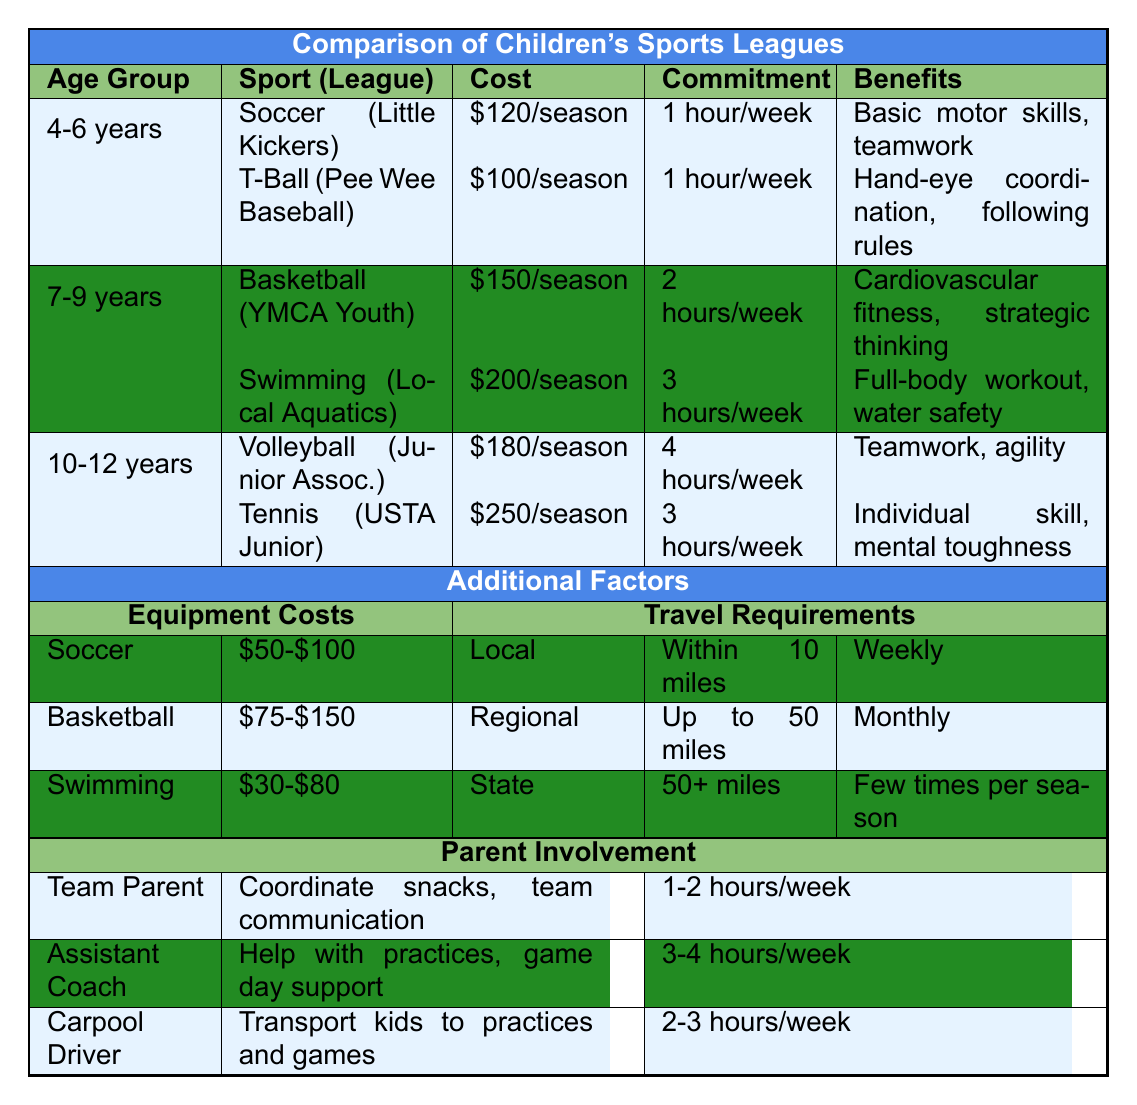What is the cost of playing soccer in the 4-6 years age group? The table shows that the cost of playing soccer (Little Kickers) in the 4-6 years age group is $120 per season.
Answer: $120/season How many hours per week do kids in the 10-12 years age group commit to volleyball? According to the table, kids in the 10-12 years age group commit to 4 hours per week for volleyball.
Answer: 4 hours/week Which sport in the 7-9 years age group has the highest cost? The table lists swimming with a cost of $200/season, which is higher than basketball's $150/season in the 7-9 years age group.
Answer: Swimming What are the total hours per week committed to sports for the 10-12 years age group? Volleyball requires 4 hours/week and tennis requires 3 hours/week. The total commitment is 4 + 3 = 7 hours/week.
Answer: 7 hours/week Is there a sport in the 4-6 years age group that has a commitment level higher than 1 hour per week? The table indicates that both soccer and T-Ball in this age group have a commitment of 1 hour/week, so there is no sport with a commitment level higher than that.
Answer: No Which sport requires the least amount of equipment cost in the 7-9 years age group? The equipment cost for basketball ranges from $75-$150 and for swimming, it ranges from $30-$80. Swimming has the least equipment cost.
Answer: Swimming If a parent wants to be a team parent for basketball in the 7-9 years group, what is their weekly time commitment? The table states that a team parent has a time commitment of 1-2 hours/week, which applies to the basketball in the 7-9 years group as well.
Answer: 1-2 hours/week What is the difference in cost between playing tennis and swimming for the 10-12 years age group? Tennis costs $250/season and swimming costs $200/season. The difference is $250 - $200 = $50.
Answer: $50 For the 4-6 years age group, how many sports are offered, and what benefits do they provide? There are two sports offered: soccer provides basic motor skills and teamwork, and T-Ball provides hand-eye coordination and following rules.
Answer: 2 sports; benefits are motor skills, teamwork, hand-eye coordination, and following rules Is carpooling required more often if a child is in the swimming league compared to the soccer league? The travel requirements are the same (local travel) for both swimming and soccer, which is within 10 miles on a weekly basis. Hence, carpooling is required equally for both.
Answer: No 